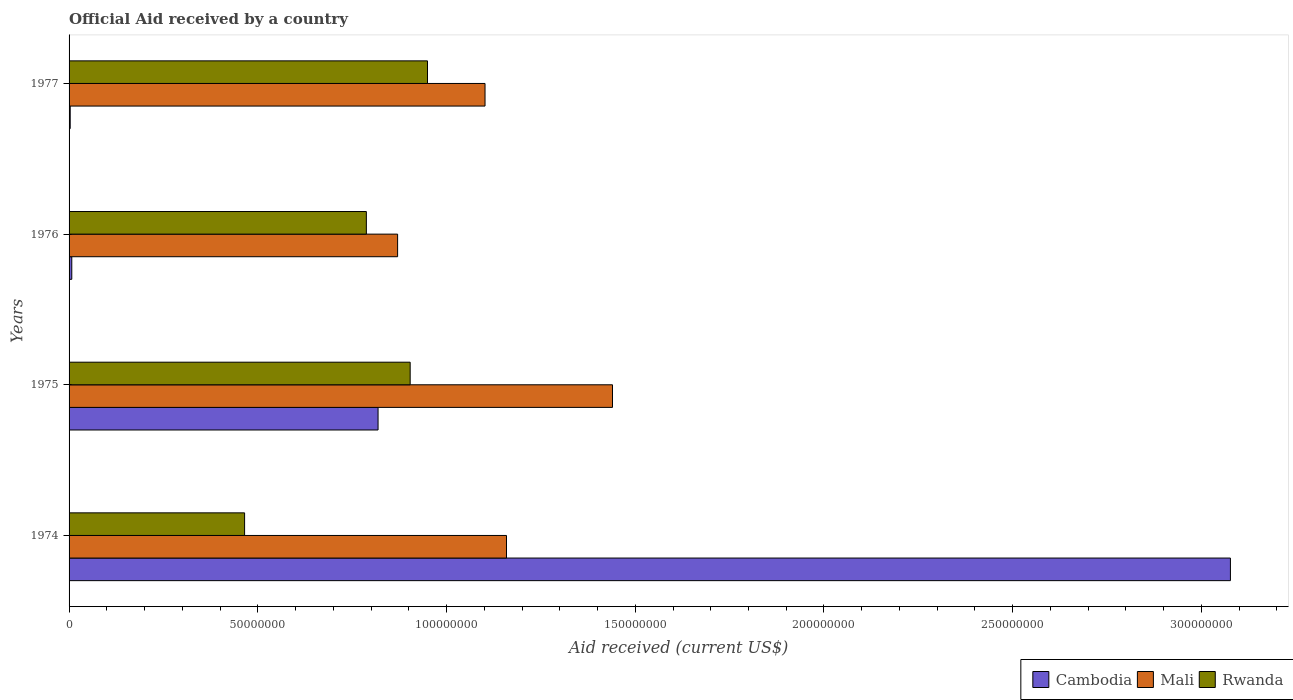How many different coloured bars are there?
Provide a short and direct response. 3. How many groups of bars are there?
Your response must be concise. 4. How many bars are there on the 2nd tick from the top?
Offer a very short reply. 3. What is the label of the 3rd group of bars from the top?
Your answer should be very brief. 1975. What is the net official aid received in Rwanda in 1977?
Offer a terse response. 9.50e+07. Across all years, what is the maximum net official aid received in Cambodia?
Your response must be concise. 3.08e+08. Across all years, what is the minimum net official aid received in Cambodia?
Give a very brief answer. 3.00e+05. In which year was the net official aid received in Cambodia maximum?
Provide a succinct answer. 1974. In which year was the net official aid received in Cambodia minimum?
Provide a short and direct response. 1977. What is the total net official aid received in Mali in the graph?
Make the answer very short. 4.57e+08. What is the difference between the net official aid received in Rwanda in 1975 and that in 1977?
Your response must be concise. -4.59e+06. What is the difference between the net official aid received in Rwanda in 1975 and the net official aid received in Mali in 1976?
Ensure brevity in your answer.  3.33e+06. What is the average net official aid received in Cambodia per year?
Provide a short and direct response. 9.76e+07. In the year 1977, what is the difference between the net official aid received in Rwanda and net official aid received in Cambodia?
Provide a short and direct response. 9.47e+07. What is the ratio of the net official aid received in Rwanda in 1975 to that in 1976?
Your answer should be very brief. 1.15. Is the difference between the net official aid received in Rwanda in 1975 and 1977 greater than the difference between the net official aid received in Cambodia in 1975 and 1977?
Your answer should be compact. No. What is the difference between the highest and the second highest net official aid received in Rwanda?
Offer a terse response. 4.59e+06. What is the difference between the highest and the lowest net official aid received in Mali?
Keep it short and to the point. 5.69e+07. What does the 2nd bar from the top in 1976 represents?
Make the answer very short. Mali. What does the 1st bar from the bottom in 1976 represents?
Offer a terse response. Cambodia. Is it the case that in every year, the sum of the net official aid received in Mali and net official aid received in Cambodia is greater than the net official aid received in Rwanda?
Ensure brevity in your answer.  Yes. Are all the bars in the graph horizontal?
Make the answer very short. Yes. How many years are there in the graph?
Ensure brevity in your answer.  4. What is the difference between two consecutive major ticks on the X-axis?
Your response must be concise. 5.00e+07. Are the values on the major ticks of X-axis written in scientific E-notation?
Ensure brevity in your answer.  No. Does the graph contain grids?
Keep it short and to the point. No. How are the legend labels stacked?
Offer a terse response. Horizontal. What is the title of the graph?
Provide a short and direct response. Official Aid received by a country. What is the label or title of the X-axis?
Offer a very short reply. Aid received (current US$). What is the label or title of the Y-axis?
Give a very brief answer. Years. What is the Aid received (current US$) in Cambodia in 1974?
Give a very brief answer. 3.08e+08. What is the Aid received (current US$) of Mali in 1974?
Your answer should be very brief. 1.16e+08. What is the Aid received (current US$) of Rwanda in 1974?
Your response must be concise. 4.65e+07. What is the Aid received (current US$) of Cambodia in 1975?
Provide a short and direct response. 8.19e+07. What is the Aid received (current US$) in Mali in 1975?
Your response must be concise. 1.44e+08. What is the Aid received (current US$) in Rwanda in 1975?
Provide a short and direct response. 9.04e+07. What is the Aid received (current US$) of Cambodia in 1976?
Keep it short and to the point. 7.20e+05. What is the Aid received (current US$) in Mali in 1976?
Offer a terse response. 8.70e+07. What is the Aid received (current US$) of Rwanda in 1976?
Make the answer very short. 7.88e+07. What is the Aid received (current US$) of Mali in 1977?
Provide a succinct answer. 1.10e+08. What is the Aid received (current US$) of Rwanda in 1977?
Keep it short and to the point. 9.50e+07. Across all years, what is the maximum Aid received (current US$) in Cambodia?
Make the answer very short. 3.08e+08. Across all years, what is the maximum Aid received (current US$) in Mali?
Offer a very short reply. 1.44e+08. Across all years, what is the maximum Aid received (current US$) in Rwanda?
Make the answer very short. 9.50e+07. Across all years, what is the minimum Aid received (current US$) in Cambodia?
Offer a terse response. 3.00e+05. Across all years, what is the minimum Aid received (current US$) in Mali?
Your answer should be very brief. 8.70e+07. Across all years, what is the minimum Aid received (current US$) in Rwanda?
Your response must be concise. 4.65e+07. What is the total Aid received (current US$) in Cambodia in the graph?
Keep it short and to the point. 3.91e+08. What is the total Aid received (current US$) in Mali in the graph?
Make the answer very short. 4.57e+08. What is the total Aid received (current US$) of Rwanda in the graph?
Your response must be concise. 3.11e+08. What is the difference between the Aid received (current US$) of Cambodia in 1974 and that in 1975?
Your response must be concise. 2.26e+08. What is the difference between the Aid received (current US$) of Mali in 1974 and that in 1975?
Offer a very short reply. -2.81e+07. What is the difference between the Aid received (current US$) of Rwanda in 1974 and that in 1975?
Your response must be concise. -4.39e+07. What is the difference between the Aid received (current US$) of Cambodia in 1974 and that in 1976?
Make the answer very short. 3.07e+08. What is the difference between the Aid received (current US$) of Mali in 1974 and that in 1976?
Ensure brevity in your answer.  2.88e+07. What is the difference between the Aid received (current US$) in Rwanda in 1974 and that in 1976?
Ensure brevity in your answer.  -3.23e+07. What is the difference between the Aid received (current US$) of Cambodia in 1974 and that in 1977?
Keep it short and to the point. 3.07e+08. What is the difference between the Aid received (current US$) in Mali in 1974 and that in 1977?
Ensure brevity in your answer.  5.69e+06. What is the difference between the Aid received (current US$) of Rwanda in 1974 and that in 1977?
Your answer should be compact. -4.85e+07. What is the difference between the Aid received (current US$) of Cambodia in 1975 and that in 1976?
Offer a terse response. 8.11e+07. What is the difference between the Aid received (current US$) in Mali in 1975 and that in 1976?
Provide a succinct answer. 5.69e+07. What is the difference between the Aid received (current US$) in Rwanda in 1975 and that in 1976?
Make the answer very short. 1.16e+07. What is the difference between the Aid received (current US$) of Cambodia in 1975 and that in 1977?
Make the answer very short. 8.16e+07. What is the difference between the Aid received (current US$) of Mali in 1975 and that in 1977?
Your response must be concise. 3.38e+07. What is the difference between the Aid received (current US$) of Rwanda in 1975 and that in 1977?
Make the answer very short. -4.59e+06. What is the difference between the Aid received (current US$) in Cambodia in 1976 and that in 1977?
Offer a terse response. 4.20e+05. What is the difference between the Aid received (current US$) in Mali in 1976 and that in 1977?
Your answer should be very brief. -2.32e+07. What is the difference between the Aid received (current US$) of Rwanda in 1976 and that in 1977?
Make the answer very short. -1.62e+07. What is the difference between the Aid received (current US$) in Cambodia in 1974 and the Aid received (current US$) in Mali in 1975?
Keep it short and to the point. 1.64e+08. What is the difference between the Aid received (current US$) in Cambodia in 1974 and the Aid received (current US$) in Rwanda in 1975?
Provide a short and direct response. 2.17e+08. What is the difference between the Aid received (current US$) in Mali in 1974 and the Aid received (current US$) in Rwanda in 1975?
Make the answer very short. 2.55e+07. What is the difference between the Aid received (current US$) in Cambodia in 1974 and the Aid received (current US$) in Mali in 1976?
Offer a terse response. 2.21e+08. What is the difference between the Aid received (current US$) of Cambodia in 1974 and the Aid received (current US$) of Rwanda in 1976?
Ensure brevity in your answer.  2.29e+08. What is the difference between the Aid received (current US$) of Mali in 1974 and the Aid received (current US$) of Rwanda in 1976?
Your answer should be compact. 3.71e+07. What is the difference between the Aid received (current US$) of Cambodia in 1974 and the Aid received (current US$) of Mali in 1977?
Your answer should be very brief. 1.97e+08. What is the difference between the Aid received (current US$) in Cambodia in 1974 and the Aid received (current US$) in Rwanda in 1977?
Offer a terse response. 2.13e+08. What is the difference between the Aid received (current US$) of Mali in 1974 and the Aid received (current US$) of Rwanda in 1977?
Your answer should be very brief. 2.09e+07. What is the difference between the Aid received (current US$) of Cambodia in 1975 and the Aid received (current US$) of Mali in 1976?
Your answer should be compact. -5.18e+06. What is the difference between the Aid received (current US$) of Cambodia in 1975 and the Aid received (current US$) of Rwanda in 1976?
Your answer should be very brief. 3.10e+06. What is the difference between the Aid received (current US$) in Mali in 1975 and the Aid received (current US$) in Rwanda in 1976?
Keep it short and to the point. 6.52e+07. What is the difference between the Aid received (current US$) in Cambodia in 1975 and the Aid received (current US$) in Mali in 1977?
Make the answer very short. -2.83e+07. What is the difference between the Aid received (current US$) in Cambodia in 1975 and the Aid received (current US$) in Rwanda in 1977?
Give a very brief answer. -1.31e+07. What is the difference between the Aid received (current US$) in Mali in 1975 and the Aid received (current US$) in Rwanda in 1977?
Provide a succinct answer. 4.90e+07. What is the difference between the Aid received (current US$) in Cambodia in 1976 and the Aid received (current US$) in Mali in 1977?
Provide a succinct answer. -1.09e+08. What is the difference between the Aid received (current US$) in Cambodia in 1976 and the Aid received (current US$) in Rwanda in 1977?
Offer a terse response. -9.42e+07. What is the difference between the Aid received (current US$) in Mali in 1976 and the Aid received (current US$) in Rwanda in 1977?
Offer a terse response. -7.92e+06. What is the average Aid received (current US$) in Cambodia per year?
Give a very brief answer. 9.76e+07. What is the average Aid received (current US$) in Mali per year?
Your answer should be compact. 1.14e+08. What is the average Aid received (current US$) in Rwanda per year?
Provide a succinct answer. 7.76e+07. In the year 1974, what is the difference between the Aid received (current US$) of Cambodia and Aid received (current US$) of Mali?
Ensure brevity in your answer.  1.92e+08. In the year 1974, what is the difference between the Aid received (current US$) of Cambodia and Aid received (current US$) of Rwanda?
Give a very brief answer. 2.61e+08. In the year 1974, what is the difference between the Aid received (current US$) of Mali and Aid received (current US$) of Rwanda?
Your answer should be very brief. 6.94e+07. In the year 1975, what is the difference between the Aid received (current US$) in Cambodia and Aid received (current US$) in Mali?
Give a very brief answer. -6.21e+07. In the year 1975, what is the difference between the Aid received (current US$) in Cambodia and Aid received (current US$) in Rwanda?
Make the answer very short. -8.51e+06. In the year 1975, what is the difference between the Aid received (current US$) of Mali and Aid received (current US$) of Rwanda?
Provide a succinct answer. 5.36e+07. In the year 1976, what is the difference between the Aid received (current US$) of Cambodia and Aid received (current US$) of Mali?
Give a very brief answer. -8.63e+07. In the year 1976, what is the difference between the Aid received (current US$) in Cambodia and Aid received (current US$) in Rwanda?
Your response must be concise. -7.80e+07. In the year 1976, what is the difference between the Aid received (current US$) in Mali and Aid received (current US$) in Rwanda?
Your answer should be compact. 8.28e+06. In the year 1977, what is the difference between the Aid received (current US$) in Cambodia and Aid received (current US$) in Mali?
Keep it short and to the point. -1.10e+08. In the year 1977, what is the difference between the Aid received (current US$) of Cambodia and Aid received (current US$) of Rwanda?
Your answer should be very brief. -9.47e+07. In the year 1977, what is the difference between the Aid received (current US$) in Mali and Aid received (current US$) in Rwanda?
Offer a very short reply. 1.52e+07. What is the ratio of the Aid received (current US$) in Cambodia in 1974 to that in 1975?
Your answer should be compact. 3.76. What is the ratio of the Aid received (current US$) of Mali in 1974 to that in 1975?
Offer a very short reply. 0.81. What is the ratio of the Aid received (current US$) of Rwanda in 1974 to that in 1975?
Provide a succinct answer. 0.51. What is the ratio of the Aid received (current US$) in Cambodia in 1974 to that in 1976?
Make the answer very short. 427.33. What is the ratio of the Aid received (current US$) of Mali in 1974 to that in 1976?
Ensure brevity in your answer.  1.33. What is the ratio of the Aid received (current US$) of Rwanda in 1974 to that in 1976?
Keep it short and to the point. 0.59. What is the ratio of the Aid received (current US$) in Cambodia in 1974 to that in 1977?
Your answer should be very brief. 1025.6. What is the ratio of the Aid received (current US$) in Mali in 1974 to that in 1977?
Give a very brief answer. 1.05. What is the ratio of the Aid received (current US$) of Rwanda in 1974 to that in 1977?
Provide a succinct answer. 0.49. What is the ratio of the Aid received (current US$) in Cambodia in 1975 to that in 1976?
Offer a terse response. 113.69. What is the ratio of the Aid received (current US$) of Mali in 1975 to that in 1976?
Offer a terse response. 1.65. What is the ratio of the Aid received (current US$) of Rwanda in 1975 to that in 1976?
Make the answer very short. 1.15. What is the ratio of the Aid received (current US$) in Cambodia in 1975 to that in 1977?
Make the answer very short. 272.87. What is the ratio of the Aid received (current US$) of Mali in 1975 to that in 1977?
Your response must be concise. 1.31. What is the ratio of the Aid received (current US$) of Rwanda in 1975 to that in 1977?
Offer a terse response. 0.95. What is the ratio of the Aid received (current US$) in Mali in 1976 to that in 1977?
Provide a succinct answer. 0.79. What is the ratio of the Aid received (current US$) in Rwanda in 1976 to that in 1977?
Provide a succinct answer. 0.83. What is the difference between the highest and the second highest Aid received (current US$) in Cambodia?
Offer a terse response. 2.26e+08. What is the difference between the highest and the second highest Aid received (current US$) of Mali?
Provide a short and direct response. 2.81e+07. What is the difference between the highest and the second highest Aid received (current US$) in Rwanda?
Provide a succinct answer. 4.59e+06. What is the difference between the highest and the lowest Aid received (current US$) in Cambodia?
Make the answer very short. 3.07e+08. What is the difference between the highest and the lowest Aid received (current US$) of Mali?
Offer a very short reply. 5.69e+07. What is the difference between the highest and the lowest Aid received (current US$) in Rwanda?
Your answer should be compact. 4.85e+07. 